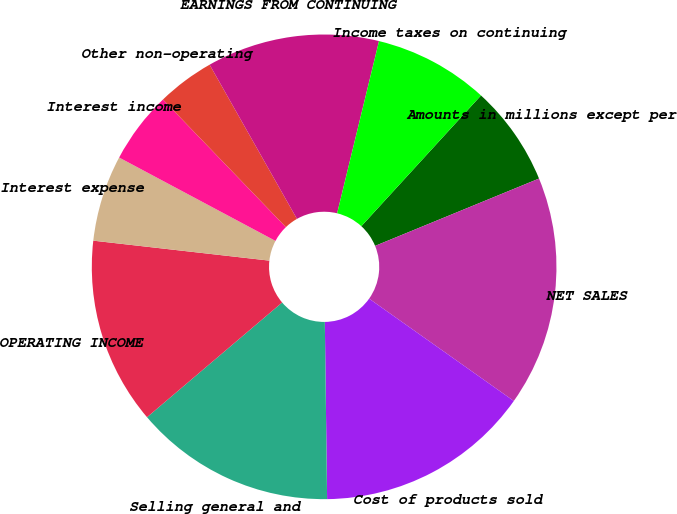Convert chart to OTSL. <chart><loc_0><loc_0><loc_500><loc_500><pie_chart><fcel>Amounts in millions except per<fcel>NET SALES<fcel>Cost of products sold<fcel>Selling general and<fcel>OPERATING INCOME<fcel>Interest expense<fcel>Interest income<fcel>Other non-operating<fcel>EARNINGS FROM CONTINUING<fcel>Income taxes on continuing<nl><fcel>7.0%<fcel>16.0%<fcel>15.0%<fcel>14.0%<fcel>13.0%<fcel>6.0%<fcel>5.0%<fcel>4.0%<fcel>12.0%<fcel>8.0%<nl></chart> 